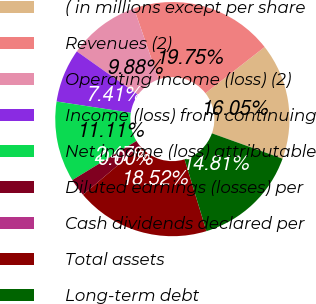Convert chart to OTSL. <chart><loc_0><loc_0><loc_500><loc_500><pie_chart><fcel>( in millions except per share<fcel>Revenues (2)<fcel>Operating income (loss) (2)<fcel>Income (loss) from continuing<fcel>Net income (loss) attributable<fcel>Diluted earnings (losses) per<fcel>Cash dividends declared per<fcel>Total assets<fcel>Long-term debt<nl><fcel>16.05%<fcel>19.75%<fcel>9.88%<fcel>7.41%<fcel>11.11%<fcel>2.47%<fcel>0.0%<fcel>18.52%<fcel>14.81%<nl></chart> 